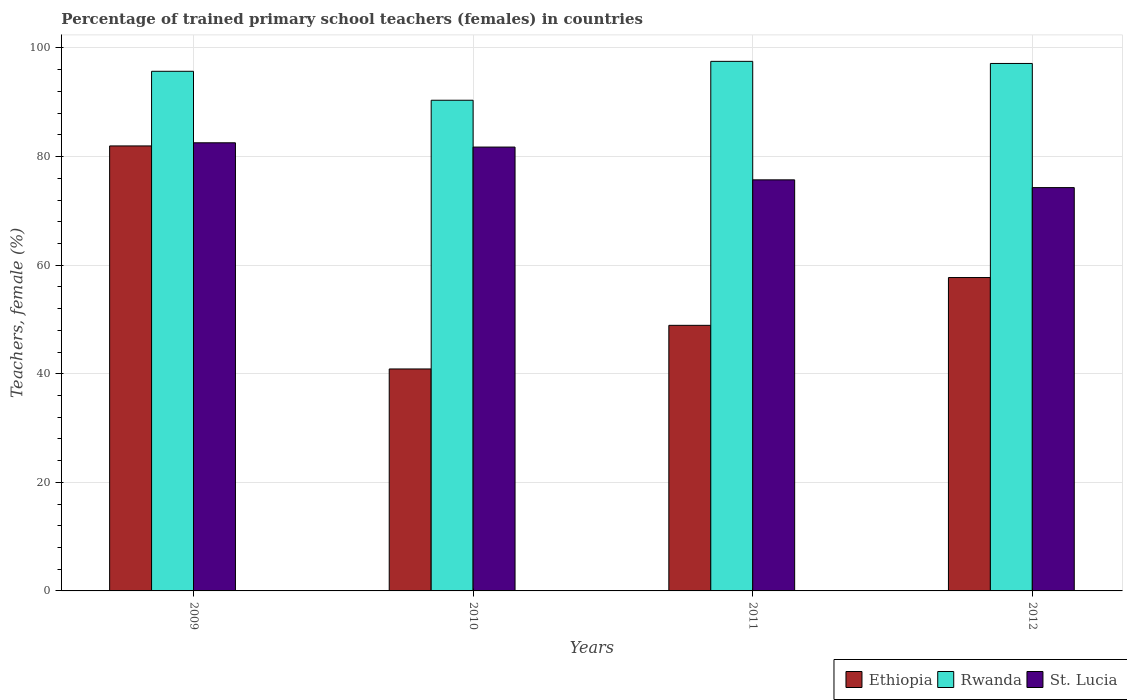How many different coloured bars are there?
Your answer should be very brief. 3. Are the number of bars on each tick of the X-axis equal?
Offer a terse response. Yes. How many bars are there on the 2nd tick from the right?
Provide a succinct answer. 3. What is the label of the 4th group of bars from the left?
Provide a succinct answer. 2012. What is the percentage of trained primary school teachers (females) in St. Lucia in 2010?
Give a very brief answer. 81.75. Across all years, what is the maximum percentage of trained primary school teachers (females) in Rwanda?
Keep it short and to the point. 97.54. Across all years, what is the minimum percentage of trained primary school teachers (females) in St. Lucia?
Offer a very short reply. 74.29. In which year was the percentage of trained primary school teachers (females) in St. Lucia minimum?
Keep it short and to the point. 2012. What is the total percentage of trained primary school teachers (females) in Rwanda in the graph?
Offer a very short reply. 380.78. What is the difference between the percentage of trained primary school teachers (females) in Rwanda in 2011 and that in 2012?
Your answer should be compact. 0.39. What is the difference between the percentage of trained primary school teachers (females) in Rwanda in 2011 and the percentage of trained primary school teachers (females) in St. Lucia in 2010?
Offer a terse response. 15.79. What is the average percentage of trained primary school teachers (females) in St. Lucia per year?
Your answer should be compact. 78.57. In the year 2011, what is the difference between the percentage of trained primary school teachers (females) in Ethiopia and percentage of trained primary school teachers (females) in St. Lucia?
Offer a very short reply. -26.8. In how many years, is the percentage of trained primary school teachers (females) in Rwanda greater than 24 %?
Give a very brief answer. 4. What is the ratio of the percentage of trained primary school teachers (females) in St. Lucia in 2009 to that in 2012?
Provide a short and direct response. 1.11. What is the difference between the highest and the second highest percentage of trained primary school teachers (females) in Ethiopia?
Your answer should be very brief. 24.24. What is the difference between the highest and the lowest percentage of trained primary school teachers (females) in Rwanda?
Provide a short and direct response. 7.16. Is the sum of the percentage of trained primary school teachers (females) in Ethiopia in 2011 and 2012 greater than the maximum percentage of trained primary school teachers (females) in St. Lucia across all years?
Offer a very short reply. Yes. What does the 1st bar from the left in 2012 represents?
Make the answer very short. Ethiopia. What does the 1st bar from the right in 2012 represents?
Your response must be concise. St. Lucia. How many bars are there?
Your answer should be compact. 12. How many years are there in the graph?
Make the answer very short. 4. What is the difference between two consecutive major ticks on the Y-axis?
Provide a short and direct response. 20. Does the graph contain grids?
Make the answer very short. Yes. What is the title of the graph?
Your answer should be very brief. Percentage of trained primary school teachers (females) in countries. What is the label or title of the X-axis?
Make the answer very short. Years. What is the label or title of the Y-axis?
Offer a very short reply. Teachers, female (%). What is the Teachers, female (%) of Ethiopia in 2009?
Provide a short and direct response. 81.96. What is the Teachers, female (%) in Rwanda in 2009?
Offer a terse response. 95.71. What is the Teachers, female (%) in St. Lucia in 2009?
Provide a succinct answer. 82.54. What is the Teachers, female (%) of Ethiopia in 2010?
Provide a short and direct response. 40.88. What is the Teachers, female (%) in Rwanda in 2010?
Ensure brevity in your answer.  90.38. What is the Teachers, female (%) in St. Lucia in 2010?
Provide a short and direct response. 81.75. What is the Teachers, female (%) of Ethiopia in 2011?
Keep it short and to the point. 48.92. What is the Teachers, female (%) of Rwanda in 2011?
Offer a very short reply. 97.54. What is the Teachers, female (%) in St. Lucia in 2011?
Keep it short and to the point. 75.71. What is the Teachers, female (%) in Ethiopia in 2012?
Give a very brief answer. 57.72. What is the Teachers, female (%) of Rwanda in 2012?
Keep it short and to the point. 97.15. What is the Teachers, female (%) of St. Lucia in 2012?
Offer a terse response. 74.29. Across all years, what is the maximum Teachers, female (%) in Ethiopia?
Your response must be concise. 81.96. Across all years, what is the maximum Teachers, female (%) in Rwanda?
Offer a terse response. 97.54. Across all years, what is the maximum Teachers, female (%) in St. Lucia?
Ensure brevity in your answer.  82.54. Across all years, what is the minimum Teachers, female (%) of Ethiopia?
Offer a very short reply. 40.88. Across all years, what is the minimum Teachers, female (%) in Rwanda?
Ensure brevity in your answer.  90.38. Across all years, what is the minimum Teachers, female (%) in St. Lucia?
Make the answer very short. 74.29. What is the total Teachers, female (%) in Ethiopia in the graph?
Make the answer very short. 229.48. What is the total Teachers, female (%) in Rwanda in the graph?
Give a very brief answer. 380.78. What is the total Teachers, female (%) of St. Lucia in the graph?
Offer a very short reply. 314.29. What is the difference between the Teachers, female (%) in Ethiopia in 2009 and that in 2010?
Your response must be concise. 41.08. What is the difference between the Teachers, female (%) of Rwanda in 2009 and that in 2010?
Make the answer very short. 5.33. What is the difference between the Teachers, female (%) of St. Lucia in 2009 and that in 2010?
Your answer should be very brief. 0.79. What is the difference between the Teachers, female (%) of Ethiopia in 2009 and that in 2011?
Make the answer very short. 33.04. What is the difference between the Teachers, female (%) in Rwanda in 2009 and that in 2011?
Provide a succinct answer. -1.83. What is the difference between the Teachers, female (%) of St. Lucia in 2009 and that in 2011?
Your answer should be compact. 6.83. What is the difference between the Teachers, female (%) in Ethiopia in 2009 and that in 2012?
Ensure brevity in your answer.  24.24. What is the difference between the Teachers, female (%) of Rwanda in 2009 and that in 2012?
Offer a very short reply. -1.44. What is the difference between the Teachers, female (%) of St. Lucia in 2009 and that in 2012?
Your response must be concise. 8.25. What is the difference between the Teachers, female (%) of Ethiopia in 2010 and that in 2011?
Give a very brief answer. -8.04. What is the difference between the Teachers, female (%) in Rwanda in 2010 and that in 2011?
Give a very brief answer. -7.16. What is the difference between the Teachers, female (%) in St. Lucia in 2010 and that in 2011?
Your answer should be very brief. 6.04. What is the difference between the Teachers, female (%) in Ethiopia in 2010 and that in 2012?
Provide a short and direct response. -16.84. What is the difference between the Teachers, female (%) in Rwanda in 2010 and that in 2012?
Your response must be concise. -6.78. What is the difference between the Teachers, female (%) in St. Lucia in 2010 and that in 2012?
Make the answer very short. 7.47. What is the difference between the Teachers, female (%) in Ethiopia in 2011 and that in 2012?
Provide a short and direct response. -8.8. What is the difference between the Teachers, female (%) of Rwanda in 2011 and that in 2012?
Offer a very short reply. 0.39. What is the difference between the Teachers, female (%) of St. Lucia in 2011 and that in 2012?
Ensure brevity in your answer.  1.43. What is the difference between the Teachers, female (%) of Ethiopia in 2009 and the Teachers, female (%) of Rwanda in 2010?
Your answer should be very brief. -8.42. What is the difference between the Teachers, female (%) in Ethiopia in 2009 and the Teachers, female (%) in St. Lucia in 2010?
Offer a terse response. 0.21. What is the difference between the Teachers, female (%) of Rwanda in 2009 and the Teachers, female (%) of St. Lucia in 2010?
Make the answer very short. 13.96. What is the difference between the Teachers, female (%) in Ethiopia in 2009 and the Teachers, female (%) in Rwanda in 2011?
Your response must be concise. -15.58. What is the difference between the Teachers, female (%) of Ethiopia in 2009 and the Teachers, female (%) of St. Lucia in 2011?
Give a very brief answer. 6.25. What is the difference between the Teachers, female (%) of Rwanda in 2009 and the Teachers, female (%) of St. Lucia in 2011?
Make the answer very short. 19.99. What is the difference between the Teachers, female (%) of Ethiopia in 2009 and the Teachers, female (%) of Rwanda in 2012?
Keep it short and to the point. -15.19. What is the difference between the Teachers, female (%) of Ethiopia in 2009 and the Teachers, female (%) of St. Lucia in 2012?
Offer a terse response. 7.68. What is the difference between the Teachers, female (%) in Rwanda in 2009 and the Teachers, female (%) in St. Lucia in 2012?
Keep it short and to the point. 21.42. What is the difference between the Teachers, female (%) of Ethiopia in 2010 and the Teachers, female (%) of Rwanda in 2011?
Your answer should be compact. -56.66. What is the difference between the Teachers, female (%) in Ethiopia in 2010 and the Teachers, female (%) in St. Lucia in 2011?
Keep it short and to the point. -34.83. What is the difference between the Teachers, female (%) in Rwanda in 2010 and the Teachers, female (%) in St. Lucia in 2011?
Offer a very short reply. 14.66. What is the difference between the Teachers, female (%) of Ethiopia in 2010 and the Teachers, female (%) of Rwanda in 2012?
Your answer should be compact. -56.27. What is the difference between the Teachers, female (%) in Ethiopia in 2010 and the Teachers, female (%) in St. Lucia in 2012?
Provide a succinct answer. -33.4. What is the difference between the Teachers, female (%) in Rwanda in 2010 and the Teachers, female (%) in St. Lucia in 2012?
Keep it short and to the point. 16.09. What is the difference between the Teachers, female (%) in Ethiopia in 2011 and the Teachers, female (%) in Rwanda in 2012?
Your answer should be compact. -48.23. What is the difference between the Teachers, female (%) of Ethiopia in 2011 and the Teachers, female (%) of St. Lucia in 2012?
Keep it short and to the point. -25.37. What is the difference between the Teachers, female (%) of Rwanda in 2011 and the Teachers, female (%) of St. Lucia in 2012?
Your response must be concise. 23.25. What is the average Teachers, female (%) in Ethiopia per year?
Offer a terse response. 57.37. What is the average Teachers, female (%) in Rwanda per year?
Keep it short and to the point. 95.19. What is the average Teachers, female (%) of St. Lucia per year?
Make the answer very short. 78.57. In the year 2009, what is the difference between the Teachers, female (%) in Ethiopia and Teachers, female (%) in Rwanda?
Provide a short and direct response. -13.75. In the year 2009, what is the difference between the Teachers, female (%) in Ethiopia and Teachers, female (%) in St. Lucia?
Your answer should be very brief. -0.58. In the year 2009, what is the difference between the Teachers, female (%) of Rwanda and Teachers, female (%) of St. Lucia?
Make the answer very short. 13.17. In the year 2010, what is the difference between the Teachers, female (%) of Ethiopia and Teachers, female (%) of Rwanda?
Keep it short and to the point. -49.5. In the year 2010, what is the difference between the Teachers, female (%) in Ethiopia and Teachers, female (%) in St. Lucia?
Your answer should be compact. -40.87. In the year 2010, what is the difference between the Teachers, female (%) in Rwanda and Teachers, female (%) in St. Lucia?
Offer a very short reply. 8.62. In the year 2011, what is the difference between the Teachers, female (%) in Ethiopia and Teachers, female (%) in Rwanda?
Provide a succinct answer. -48.62. In the year 2011, what is the difference between the Teachers, female (%) of Ethiopia and Teachers, female (%) of St. Lucia?
Provide a succinct answer. -26.8. In the year 2011, what is the difference between the Teachers, female (%) of Rwanda and Teachers, female (%) of St. Lucia?
Offer a very short reply. 21.83. In the year 2012, what is the difference between the Teachers, female (%) of Ethiopia and Teachers, female (%) of Rwanda?
Provide a short and direct response. -39.43. In the year 2012, what is the difference between the Teachers, female (%) in Ethiopia and Teachers, female (%) in St. Lucia?
Your response must be concise. -16.56. In the year 2012, what is the difference between the Teachers, female (%) in Rwanda and Teachers, female (%) in St. Lucia?
Your answer should be compact. 22.87. What is the ratio of the Teachers, female (%) of Ethiopia in 2009 to that in 2010?
Give a very brief answer. 2. What is the ratio of the Teachers, female (%) in Rwanda in 2009 to that in 2010?
Keep it short and to the point. 1.06. What is the ratio of the Teachers, female (%) in St. Lucia in 2009 to that in 2010?
Your answer should be compact. 1.01. What is the ratio of the Teachers, female (%) in Ethiopia in 2009 to that in 2011?
Your response must be concise. 1.68. What is the ratio of the Teachers, female (%) of Rwanda in 2009 to that in 2011?
Keep it short and to the point. 0.98. What is the ratio of the Teachers, female (%) of St. Lucia in 2009 to that in 2011?
Your answer should be compact. 1.09. What is the ratio of the Teachers, female (%) of Ethiopia in 2009 to that in 2012?
Provide a short and direct response. 1.42. What is the ratio of the Teachers, female (%) of Rwanda in 2009 to that in 2012?
Your response must be concise. 0.99. What is the ratio of the Teachers, female (%) in St. Lucia in 2009 to that in 2012?
Your answer should be very brief. 1.11. What is the ratio of the Teachers, female (%) of Ethiopia in 2010 to that in 2011?
Keep it short and to the point. 0.84. What is the ratio of the Teachers, female (%) of Rwanda in 2010 to that in 2011?
Your answer should be very brief. 0.93. What is the ratio of the Teachers, female (%) in St. Lucia in 2010 to that in 2011?
Provide a succinct answer. 1.08. What is the ratio of the Teachers, female (%) in Ethiopia in 2010 to that in 2012?
Ensure brevity in your answer.  0.71. What is the ratio of the Teachers, female (%) in Rwanda in 2010 to that in 2012?
Your response must be concise. 0.93. What is the ratio of the Teachers, female (%) in St. Lucia in 2010 to that in 2012?
Your response must be concise. 1.1. What is the ratio of the Teachers, female (%) of Ethiopia in 2011 to that in 2012?
Make the answer very short. 0.85. What is the ratio of the Teachers, female (%) of St. Lucia in 2011 to that in 2012?
Your response must be concise. 1.02. What is the difference between the highest and the second highest Teachers, female (%) of Ethiopia?
Your answer should be compact. 24.24. What is the difference between the highest and the second highest Teachers, female (%) in Rwanda?
Offer a terse response. 0.39. What is the difference between the highest and the second highest Teachers, female (%) in St. Lucia?
Offer a terse response. 0.79. What is the difference between the highest and the lowest Teachers, female (%) in Ethiopia?
Make the answer very short. 41.08. What is the difference between the highest and the lowest Teachers, female (%) in Rwanda?
Your answer should be compact. 7.16. What is the difference between the highest and the lowest Teachers, female (%) in St. Lucia?
Provide a succinct answer. 8.25. 